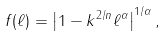Convert formula to latex. <formula><loc_0><loc_0><loc_500><loc_500>f ( \ell ) = \left | 1 - k ^ { 2 / n } \ell ^ { \alpha } \right | ^ { 1 / \alpha } ,</formula> 